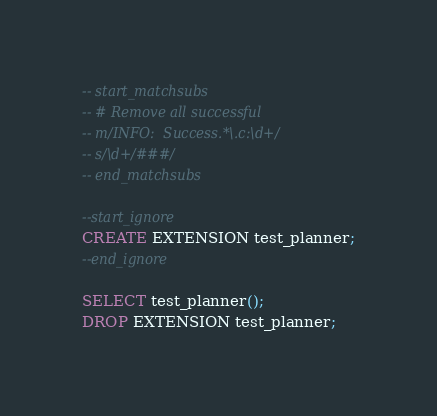<code> <loc_0><loc_0><loc_500><loc_500><_SQL_>-- start_matchsubs
-- # Remove all successful
-- m/INFO:  Success.*\.c:\d+/
-- s/\d+/###/
-- end_matchsubs

--start_ignore
CREATE EXTENSION test_planner;
--end_ignore

SELECT test_planner();
DROP EXTENSION test_planner;
</code> 